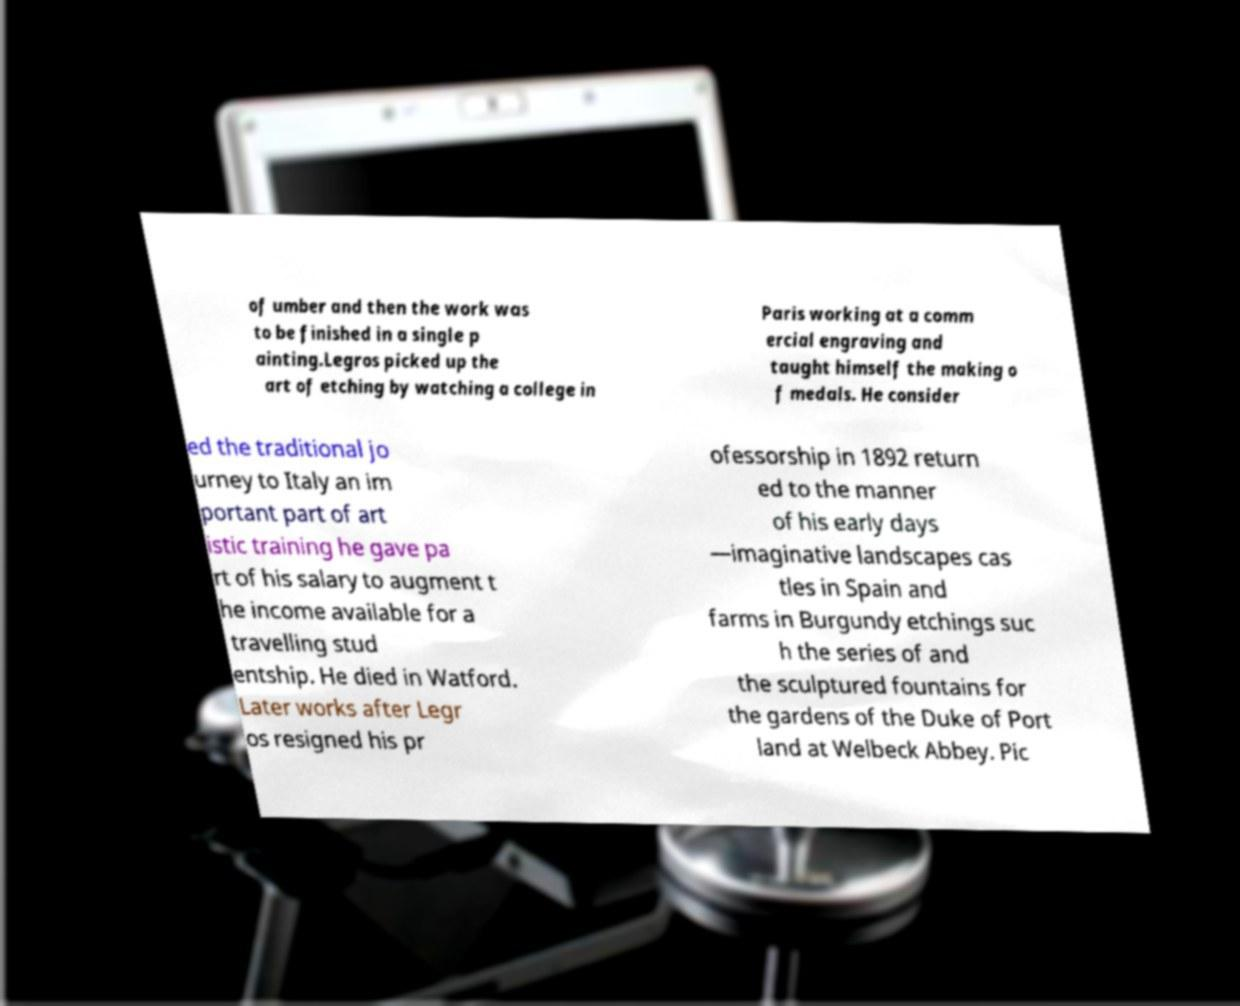Can you accurately transcribe the text from the provided image for me? of umber and then the work was to be finished in a single p ainting.Legros picked up the art of etching by watching a college in Paris working at a comm ercial engraving and taught himself the making o f medals. He consider ed the traditional jo urney to Italy an im portant part of art istic training he gave pa rt of his salary to augment t he income available for a travelling stud entship. He died in Watford. Later works after Legr os resigned his pr ofessorship in 1892 return ed to the manner of his early days —imaginative landscapes cas tles in Spain and farms in Burgundy etchings suc h the series of and the sculptured fountains for the gardens of the Duke of Port land at Welbeck Abbey. Pic 